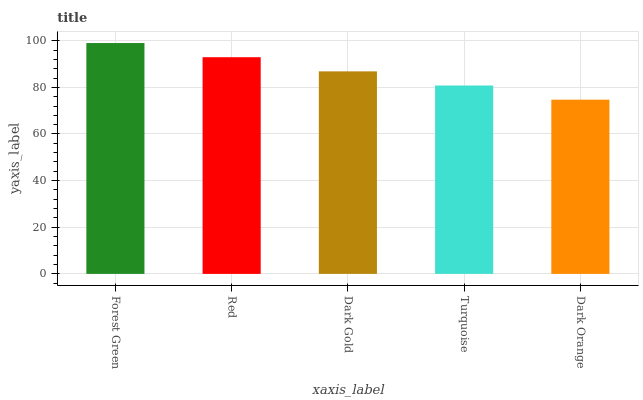Is Dark Orange the minimum?
Answer yes or no. Yes. Is Forest Green the maximum?
Answer yes or no. Yes. Is Red the minimum?
Answer yes or no. No. Is Red the maximum?
Answer yes or no. No. Is Forest Green greater than Red?
Answer yes or no. Yes. Is Red less than Forest Green?
Answer yes or no. Yes. Is Red greater than Forest Green?
Answer yes or no. No. Is Forest Green less than Red?
Answer yes or no. No. Is Dark Gold the high median?
Answer yes or no. Yes. Is Dark Gold the low median?
Answer yes or no. Yes. Is Dark Orange the high median?
Answer yes or no. No. Is Red the low median?
Answer yes or no. No. 